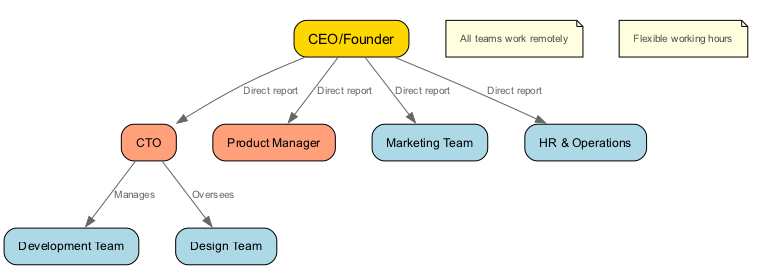What is the title of the highest-ranking person in the organization? The diagram identifies the CEO/Founder as the highest-ranking person, as he is placed at the top and has multiple direct reports below him.
Answer: CEO/Founder How many teams report directly to the CEO? By examining the edges in the diagram, we see that there are four direct reports (CTO, Product Manager, Marketing Team, HR & Operations) that connect directly to the CEO.
Answer: 4 Who manages the Development Team? The connection from the CTO to the Development Team indicates that the CTO is responsible for managing this team.
Answer: CTO Which team does the CTO oversee in addition to the Development Team? The diagram shows an edge labeled "Oversees" from the CTO to the Design Team, indicating that the CTO oversees this team.
Answer: Design Team What special working conditions are noted for all teams in the organization? The notes section of the diagram mentions that "All teams work remotely," emphasizing the remote nature of the organization.
Answer: All teams work remotely How many edges connect the CEO to other nodes? Counting the edges directly connected to the CEO in the diagram, we find that there are four edges that represent the direct report relationships to other nodes.
Answer: 4 What color is used to represent the CEO node in the diagram? The diagram features a gold fill color for the CEO node, distinguishing it from other nodes.
Answer: Gold What is mentioned about working hours in the diagram? The right note specifies "Flexible working hours," which highlights the organization's approach to work hours.
Answer: Flexible working hours How does the CTO relate to both the Development Team and Design Team? The diagram displays two edges from the CTO: one labeled "Manages" connecting to the Development Team and another labeled "Oversees" connecting to the Design Team, indicating both roles of management and oversight.
Answer: Manages and Oversees 